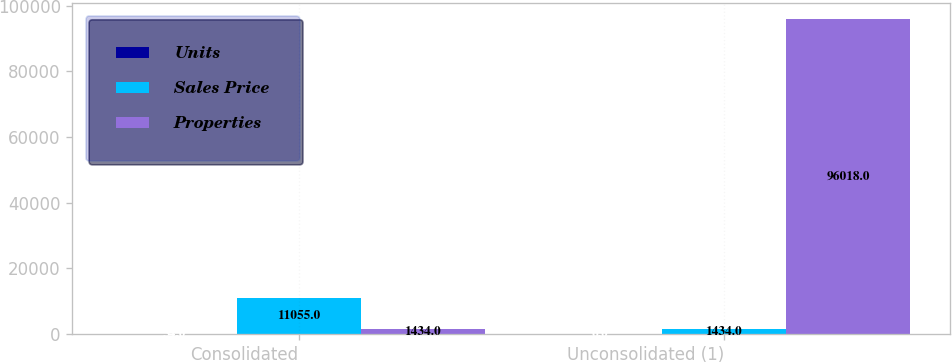<chart> <loc_0><loc_0><loc_500><loc_500><stacked_bar_chart><ecel><fcel>Consolidated<fcel>Unconsolidated (1)<nl><fcel>Units<fcel>54<fcel>6<nl><fcel>Sales Price<fcel>11055<fcel>1434<nl><fcel>Properties<fcel>1434<fcel>96018<nl></chart> 